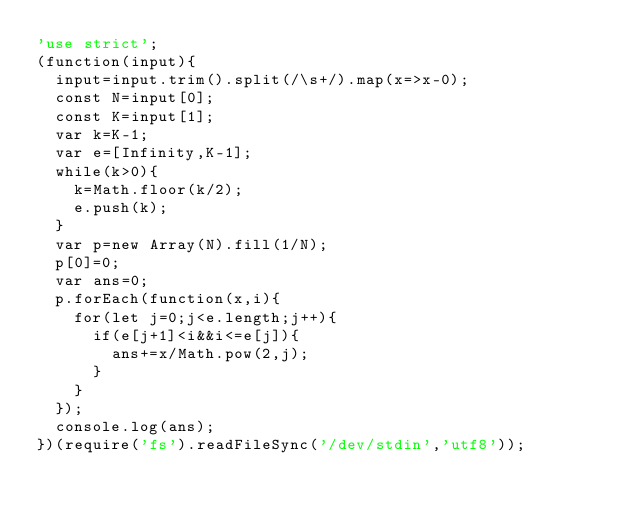<code> <loc_0><loc_0><loc_500><loc_500><_JavaScript_>'use strict';
(function(input){
  input=input.trim().split(/\s+/).map(x=>x-0);
  const N=input[0];
  const K=input[1];
  var k=K-1;
  var e=[Infinity,K-1];
  while(k>0){
    k=Math.floor(k/2);
    e.push(k);
  }
  var p=new Array(N).fill(1/N);
  p[0]=0;
  var ans=0;
  p.forEach(function(x,i){
    for(let j=0;j<e.length;j++){
      if(e[j+1]<i&&i<=e[j]){
        ans+=x/Math.pow(2,j);
      }
    }
  });
  console.log(ans);
})(require('fs').readFileSync('/dev/stdin','utf8'));
</code> 